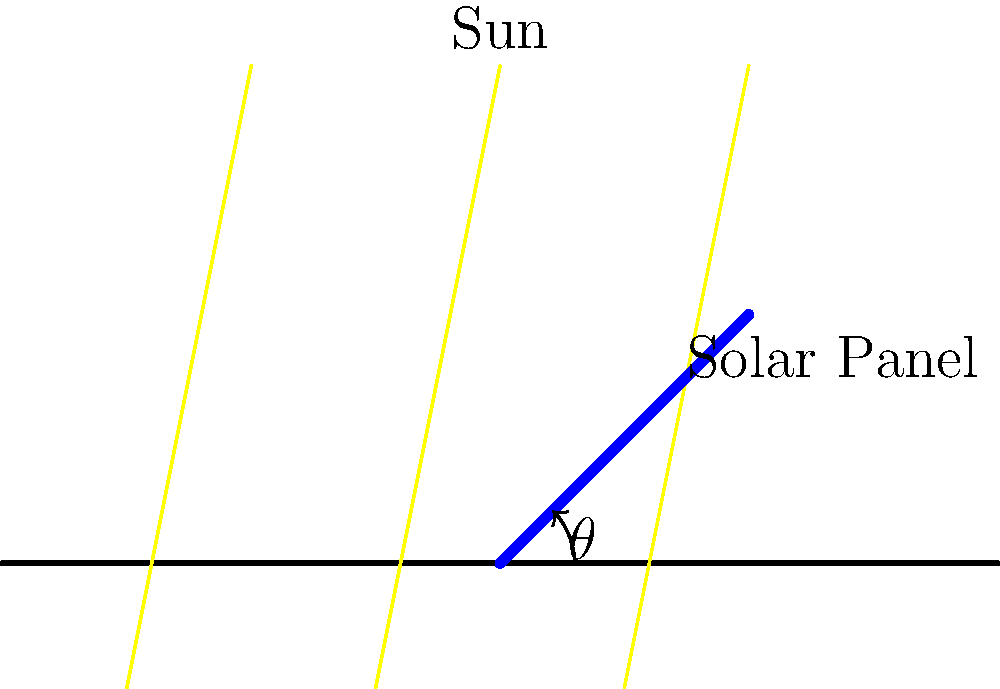As a homesteader looking to optimize your solar energy setup, you're experimenting with different panel angles. You have a solar panel tilted at an angle $\theta = 45°$ from the horizontal, and the sun's rays are directly overhead. If the panel's maximum efficiency is 20% when perpendicular to the sun's rays, what is its actual efficiency in this position? To solve this problem, we'll follow these steps:

1) The efficiency of a solar panel is directly related to the amount of sunlight it receives, which depends on the angle between the panel's surface and the sun's rays.

2) When the panel is perpendicular to the sun's rays, it receives maximum sunlight and thus has maximum efficiency (20% in this case).

3) The amount of sunlight received by the panel is proportional to the cosine of the angle between the panel's normal (perpendicular) and the sun's rays.

4) In this case, the sun is directly overhead, so the angle between the panel's normal and the sun's rays is the same as the panel's tilt angle, $\theta = 45°$.

5) The actual efficiency can be calculated by multiplying the maximum efficiency by the cosine of this angle:

   Actual Efficiency = Maximum Efficiency × cos(θ)

6) Plugging in the values:

   Actual Efficiency = 20% × cos(45°)

7) cos(45°) = $\frac{1}{\sqrt{2}} ≈ 0.7071$

8) Therefore:

   Actual Efficiency = 20% × 0.7071 = 14.14%
Answer: 14.14% 